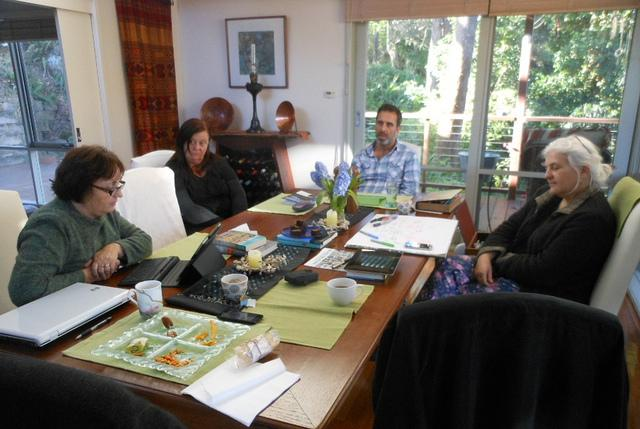What kind of gathering is this? Please explain your reasoning. business. People sit at a large table with computers and papers all around. 